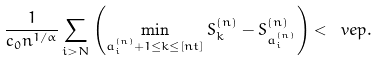<formula> <loc_0><loc_0><loc_500><loc_500>\frac { 1 } { c _ { 0 } n ^ { 1 / \alpha } } \sum _ { i > N } \left ( \min _ { a ^ { ( n ) } _ { i } + 1 \leq k \leq [ n t ] } S ^ { ( n ) } _ { k } - S ^ { ( n ) } _ { a ^ { ( n ) } _ { i } } \right ) < \ v e p .</formula> 